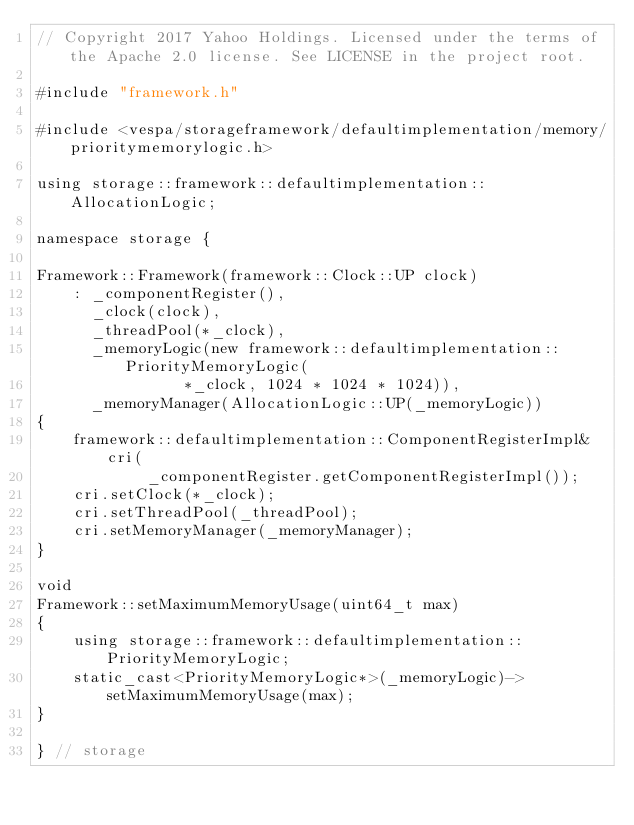<code> <loc_0><loc_0><loc_500><loc_500><_C++_>// Copyright 2017 Yahoo Holdings. Licensed under the terms of the Apache 2.0 license. See LICENSE in the project root.

#include "framework.h"

#include <vespa/storageframework/defaultimplementation/memory/prioritymemorylogic.h>

using storage::framework::defaultimplementation::AllocationLogic;

namespace storage {

Framework::Framework(framework::Clock::UP clock)
    : _componentRegister(),
      _clock(clock),
      _threadPool(*_clock),
      _memoryLogic(new framework::defaultimplementation::PriorityMemoryLogic(
                *_clock, 1024 * 1024 * 1024)),
      _memoryManager(AllocationLogic::UP(_memoryLogic))
{
    framework::defaultimplementation::ComponentRegisterImpl& cri(
            _componentRegister.getComponentRegisterImpl());
    cri.setClock(*_clock);
    cri.setThreadPool(_threadPool);
    cri.setMemoryManager(_memoryManager);
}

void
Framework::setMaximumMemoryUsage(uint64_t max)
{
    using storage::framework::defaultimplementation::PriorityMemoryLogic;
    static_cast<PriorityMemoryLogic*>(_memoryLogic)->setMaximumMemoryUsage(max);
}

} // storage
</code> 